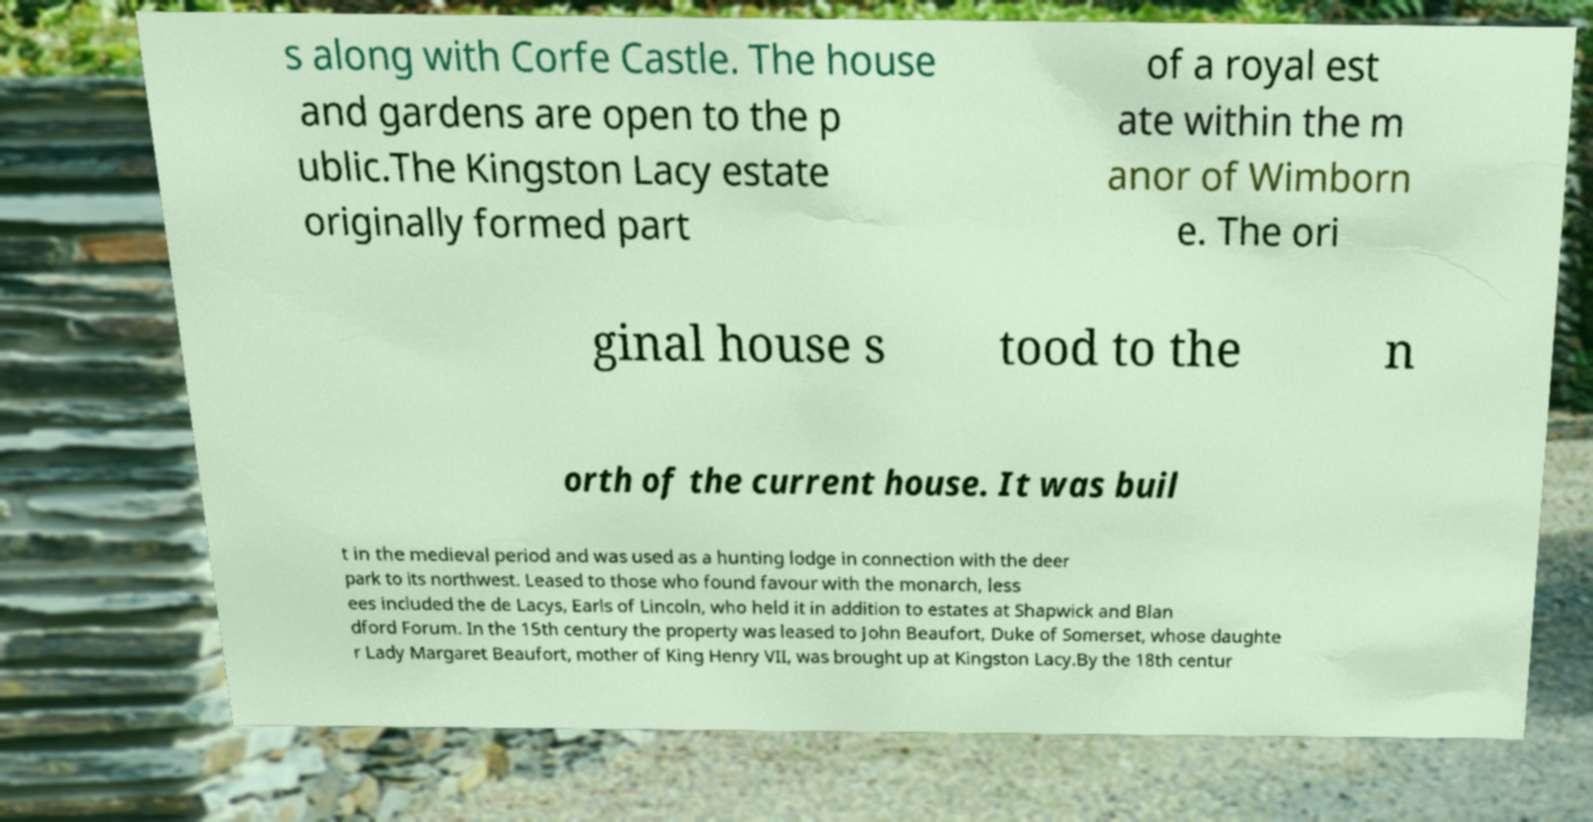I need the written content from this picture converted into text. Can you do that? s along with Corfe Castle. The house and gardens are open to the p ublic.The Kingston Lacy estate originally formed part of a royal est ate within the m anor of Wimborn e. The ori ginal house s tood to the n orth of the current house. It was buil t in the medieval period and was used as a hunting lodge in connection with the deer park to its northwest. Leased to those who found favour with the monarch, less ees included the de Lacys, Earls of Lincoln, who held it in addition to estates at Shapwick and Blan dford Forum. In the 15th century the property was leased to John Beaufort, Duke of Somerset, whose daughte r Lady Margaret Beaufort, mother of King Henry VII, was brought up at Kingston Lacy.By the 18th centur 